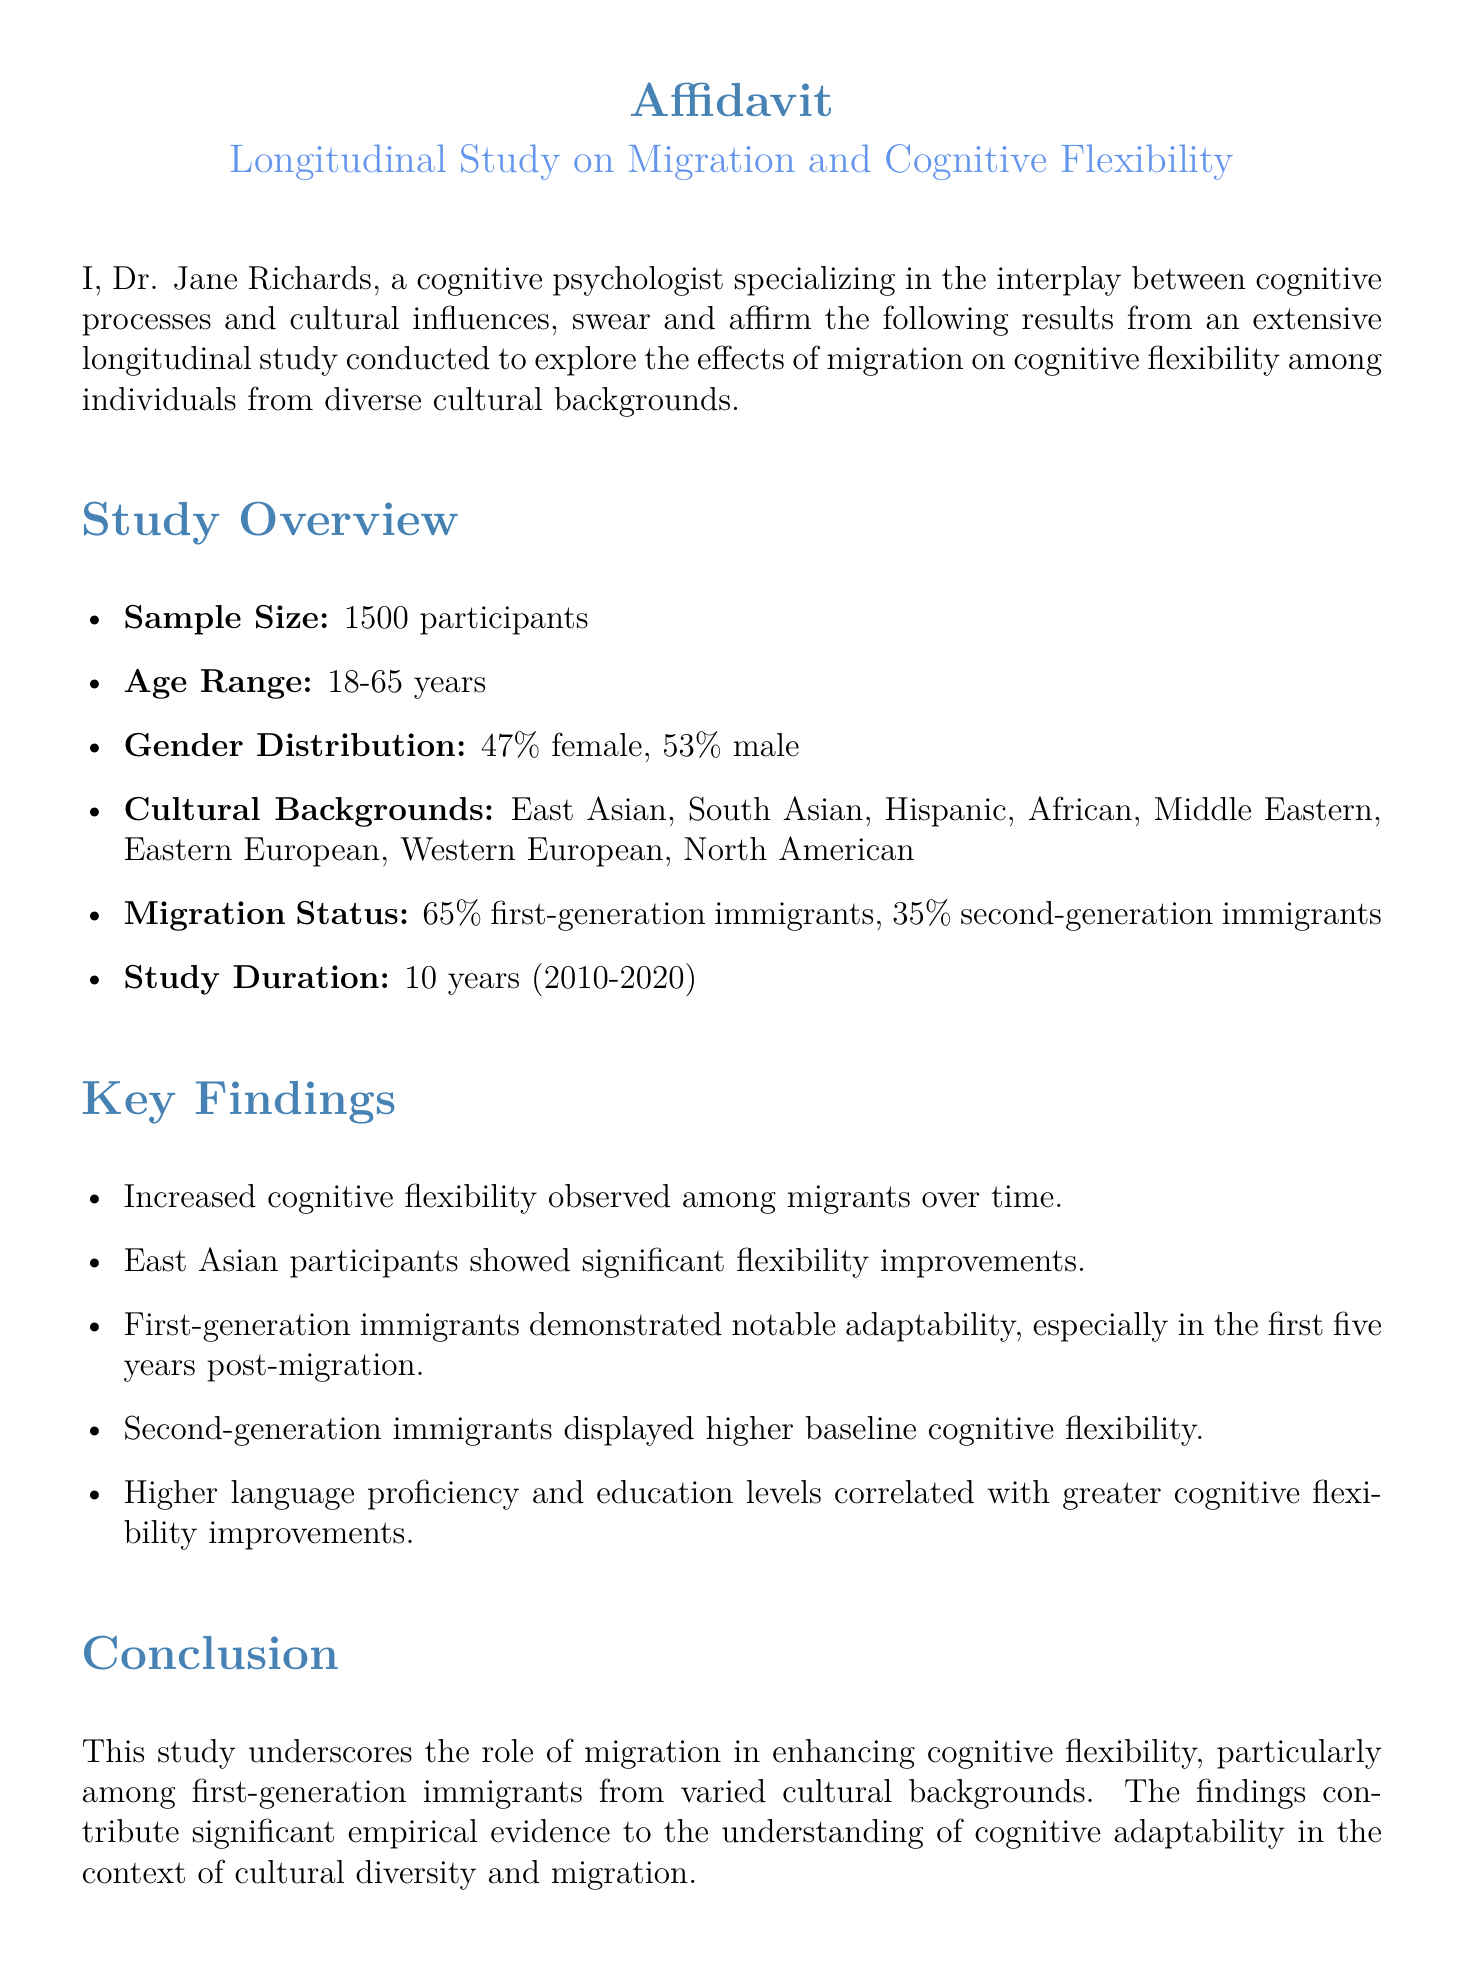What is the sample size of the study? The sample size is stated in the document as the total number of participants who took part in the study.
Answer: 1500 participants What is the age range of participants? The age range indicates the minimum and maximum ages of the participants involved in the study.
Answer: 18-65 years What percentage of participants are male? The gender distribution provides the percentage of male participants in the study.
Answer: 53% Which cultural background showed significant flexibility improvements? This question requires identifying the specific cultural group mentioned in the findings that experienced notable improvements in cognitive flexibility.
Answer: East Asian What is the duration of the study? The study duration states the total time over which the research was conducted, indicating the start and end years.
Answer: 10 years (2010-2020) What correlation was observed regarding language proficiency? This question focuses on the relationship indicated in the findings between language proficiency and cognitive flexibility.
Answer: Greater cognitive flexibility improvements What is the role of migration according to the study? This question seeks to summarize the overall conclusion regarding migration's impact as discussed in the study.
Answer: Enhancing cognitive flexibility What is the declaration made by Dr. Jane Richards? This refers to the statement made by the author affirming the truthfulness of the document's contents and findings.
Answer: True and correct On what date was the affidavit signed? This question pertains to the specific date mentioned at the end of the affidavit, marking when the document was completed.
Answer: September 25, 2023 